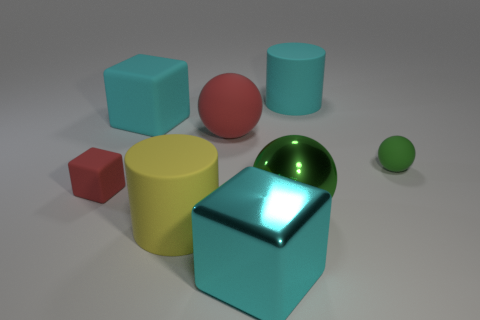What number of cylinders are big cyan rubber objects or small red rubber objects?
Your answer should be compact. 1. What is the color of the shiny cube?
Your answer should be compact. Cyan. Is the size of the cylinder behind the tiny ball the same as the cube that is to the right of the red matte ball?
Your response must be concise. Yes. Are there fewer big red metal cubes than red things?
Offer a terse response. Yes. There is a big cyan rubber block; what number of cyan rubber blocks are on the right side of it?
Offer a very short reply. 0. What material is the large cyan cylinder?
Make the answer very short. Rubber. Is the large metallic ball the same color as the metal cube?
Give a very brief answer. No. Are there fewer red things that are on the left side of the green matte object than red matte balls?
Make the answer very short. No. The large matte object right of the green metal object is what color?
Keep it short and to the point. Cyan. The big yellow rubber object is what shape?
Provide a short and direct response. Cylinder. 